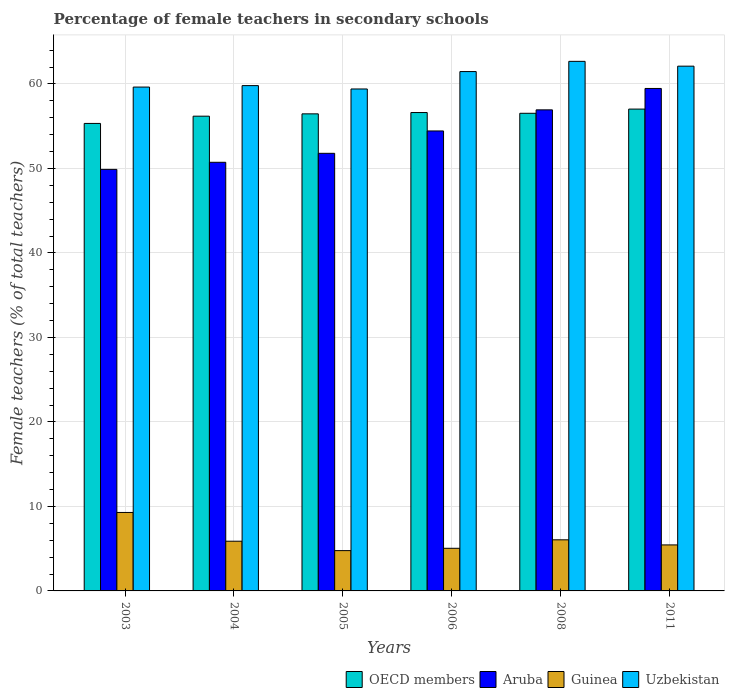Are the number of bars per tick equal to the number of legend labels?
Your response must be concise. Yes. Are the number of bars on each tick of the X-axis equal?
Offer a very short reply. Yes. What is the label of the 4th group of bars from the left?
Keep it short and to the point. 2006. What is the percentage of female teachers in Aruba in 2008?
Your response must be concise. 56.94. Across all years, what is the maximum percentage of female teachers in Aruba?
Offer a terse response. 59.47. Across all years, what is the minimum percentage of female teachers in Aruba?
Provide a succinct answer. 49.89. What is the total percentage of female teachers in Uzbekistan in the graph?
Provide a short and direct response. 365.1. What is the difference between the percentage of female teachers in Guinea in 2005 and that in 2006?
Your answer should be very brief. -0.28. What is the difference between the percentage of female teachers in Uzbekistan in 2011 and the percentage of female teachers in Guinea in 2008?
Make the answer very short. 56.06. What is the average percentage of female teachers in Guinea per year?
Offer a very short reply. 6.08. In the year 2006, what is the difference between the percentage of female teachers in OECD members and percentage of female teachers in Aruba?
Your response must be concise. 2.18. What is the ratio of the percentage of female teachers in Aruba in 2003 to that in 2006?
Provide a succinct answer. 0.92. Is the percentage of female teachers in OECD members in 2003 less than that in 2011?
Your answer should be compact. Yes. Is the difference between the percentage of female teachers in OECD members in 2003 and 2006 greater than the difference between the percentage of female teachers in Aruba in 2003 and 2006?
Make the answer very short. Yes. What is the difference between the highest and the second highest percentage of female teachers in Aruba?
Ensure brevity in your answer.  2.53. What is the difference between the highest and the lowest percentage of female teachers in OECD members?
Keep it short and to the point. 1.7. What does the 3rd bar from the left in 2003 represents?
Offer a terse response. Guinea. What does the 3rd bar from the right in 2003 represents?
Make the answer very short. Aruba. Are all the bars in the graph horizontal?
Your answer should be compact. No. How many years are there in the graph?
Give a very brief answer. 6. What is the difference between two consecutive major ticks on the Y-axis?
Ensure brevity in your answer.  10. Are the values on the major ticks of Y-axis written in scientific E-notation?
Make the answer very short. No. Where does the legend appear in the graph?
Keep it short and to the point. Bottom right. How are the legend labels stacked?
Offer a terse response. Horizontal. What is the title of the graph?
Offer a terse response. Percentage of female teachers in secondary schools. Does "Latin America(developing only)" appear as one of the legend labels in the graph?
Ensure brevity in your answer.  No. What is the label or title of the X-axis?
Your answer should be compact. Years. What is the label or title of the Y-axis?
Your answer should be compact. Female teachers (% of total teachers). What is the Female teachers (% of total teachers) in OECD members in 2003?
Offer a very short reply. 55.33. What is the Female teachers (% of total teachers) of Aruba in 2003?
Your answer should be very brief. 49.89. What is the Female teachers (% of total teachers) in Guinea in 2003?
Ensure brevity in your answer.  9.29. What is the Female teachers (% of total teachers) of Uzbekistan in 2003?
Your answer should be very brief. 59.63. What is the Female teachers (% of total teachers) in OECD members in 2004?
Your answer should be very brief. 56.19. What is the Female teachers (% of total teachers) in Aruba in 2004?
Provide a succinct answer. 50.73. What is the Female teachers (% of total teachers) of Guinea in 2004?
Your answer should be compact. 5.88. What is the Female teachers (% of total teachers) of Uzbekistan in 2004?
Your response must be concise. 59.81. What is the Female teachers (% of total teachers) of OECD members in 2005?
Your answer should be compact. 56.46. What is the Female teachers (% of total teachers) in Aruba in 2005?
Provide a short and direct response. 51.79. What is the Female teachers (% of total teachers) in Guinea in 2005?
Offer a terse response. 4.77. What is the Female teachers (% of total teachers) in Uzbekistan in 2005?
Your answer should be very brief. 59.41. What is the Female teachers (% of total teachers) of OECD members in 2006?
Make the answer very short. 56.62. What is the Female teachers (% of total teachers) of Aruba in 2006?
Ensure brevity in your answer.  54.44. What is the Female teachers (% of total teachers) of Guinea in 2006?
Provide a succinct answer. 5.05. What is the Female teachers (% of total teachers) in Uzbekistan in 2006?
Offer a very short reply. 61.47. What is the Female teachers (% of total teachers) of OECD members in 2008?
Offer a very short reply. 56.53. What is the Female teachers (% of total teachers) of Aruba in 2008?
Your response must be concise. 56.94. What is the Female teachers (% of total teachers) of Guinea in 2008?
Keep it short and to the point. 6.05. What is the Female teachers (% of total teachers) of Uzbekistan in 2008?
Ensure brevity in your answer.  62.68. What is the Female teachers (% of total teachers) in OECD members in 2011?
Your response must be concise. 57.03. What is the Female teachers (% of total teachers) in Aruba in 2011?
Keep it short and to the point. 59.47. What is the Female teachers (% of total teachers) in Guinea in 2011?
Keep it short and to the point. 5.44. What is the Female teachers (% of total teachers) of Uzbekistan in 2011?
Keep it short and to the point. 62.11. Across all years, what is the maximum Female teachers (% of total teachers) of OECD members?
Your answer should be compact. 57.03. Across all years, what is the maximum Female teachers (% of total teachers) of Aruba?
Ensure brevity in your answer.  59.47. Across all years, what is the maximum Female teachers (% of total teachers) of Guinea?
Your response must be concise. 9.29. Across all years, what is the maximum Female teachers (% of total teachers) in Uzbekistan?
Provide a succinct answer. 62.68. Across all years, what is the minimum Female teachers (% of total teachers) of OECD members?
Provide a succinct answer. 55.33. Across all years, what is the minimum Female teachers (% of total teachers) of Aruba?
Your answer should be very brief. 49.89. Across all years, what is the minimum Female teachers (% of total teachers) in Guinea?
Offer a terse response. 4.77. Across all years, what is the minimum Female teachers (% of total teachers) of Uzbekistan?
Your answer should be very brief. 59.41. What is the total Female teachers (% of total teachers) of OECD members in the graph?
Offer a terse response. 338.16. What is the total Female teachers (% of total teachers) in Aruba in the graph?
Make the answer very short. 323.26. What is the total Female teachers (% of total teachers) of Guinea in the graph?
Provide a succinct answer. 36.48. What is the total Female teachers (% of total teachers) of Uzbekistan in the graph?
Keep it short and to the point. 365.1. What is the difference between the Female teachers (% of total teachers) in OECD members in 2003 and that in 2004?
Provide a short and direct response. -0.86. What is the difference between the Female teachers (% of total teachers) of Aruba in 2003 and that in 2004?
Make the answer very short. -0.84. What is the difference between the Female teachers (% of total teachers) of Guinea in 2003 and that in 2004?
Provide a succinct answer. 3.4. What is the difference between the Female teachers (% of total teachers) of Uzbekistan in 2003 and that in 2004?
Make the answer very short. -0.17. What is the difference between the Female teachers (% of total teachers) in OECD members in 2003 and that in 2005?
Your answer should be very brief. -1.13. What is the difference between the Female teachers (% of total teachers) in Aruba in 2003 and that in 2005?
Keep it short and to the point. -1.9. What is the difference between the Female teachers (% of total teachers) of Guinea in 2003 and that in 2005?
Offer a terse response. 4.52. What is the difference between the Female teachers (% of total teachers) in Uzbekistan in 2003 and that in 2005?
Offer a very short reply. 0.22. What is the difference between the Female teachers (% of total teachers) of OECD members in 2003 and that in 2006?
Your answer should be very brief. -1.29. What is the difference between the Female teachers (% of total teachers) of Aruba in 2003 and that in 2006?
Provide a short and direct response. -4.55. What is the difference between the Female teachers (% of total teachers) in Guinea in 2003 and that in 2006?
Provide a short and direct response. 4.24. What is the difference between the Female teachers (% of total teachers) in Uzbekistan in 2003 and that in 2006?
Your answer should be compact. -1.84. What is the difference between the Female teachers (% of total teachers) of OECD members in 2003 and that in 2008?
Your answer should be very brief. -1.2. What is the difference between the Female teachers (% of total teachers) in Aruba in 2003 and that in 2008?
Provide a succinct answer. -7.05. What is the difference between the Female teachers (% of total teachers) in Guinea in 2003 and that in 2008?
Keep it short and to the point. 3.24. What is the difference between the Female teachers (% of total teachers) in Uzbekistan in 2003 and that in 2008?
Your response must be concise. -3.04. What is the difference between the Female teachers (% of total teachers) of OECD members in 2003 and that in 2011?
Give a very brief answer. -1.7. What is the difference between the Female teachers (% of total teachers) in Aruba in 2003 and that in 2011?
Ensure brevity in your answer.  -9.58. What is the difference between the Female teachers (% of total teachers) of Guinea in 2003 and that in 2011?
Your response must be concise. 3.84. What is the difference between the Female teachers (% of total teachers) in Uzbekistan in 2003 and that in 2011?
Offer a terse response. -2.47. What is the difference between the Female teachers (% of total teachers) of OECD members in 2004 and that in 2005?
Offer a terse response. -0.28. What is the difference between the Female teachers (% of total teachers) of Aruba in 2004 and that in 2005?
Offer a terse response. -1.06. What is the difference between the Female teachers (% of total teachers) in Guinea in 2004 and that in 2005?
Provide a short and direct response. 1.11. What is the difference between the Female teachers (% of total teachers) of Uzbekistan in 2004 and that in 2005?
Your answer should be compact. 0.4. What is the difference between the Female teachers (% of total teachers) of OECD members in 2004 and that in 2006?
Offer a very short reply. -0.43. What is the difference between the Female teachers (% of total teachers) of Aruba in 2004 and that in 2006?
Provide a succinct answer. -3.71. What is the difference between the Female teachers (% of total teachers) of Guinea in 2004 and that in 2006?
Ensure brevity in your answer.  0.84. What is the difference between the Female teachers (% of total teachers) of Uzbekistan in 2004 and that in 2006?
Give a very brief answer. -1.66. What is the difference between the Female teachers (% of total teachers) in OECD members in 2004 and that in 2008?
Keep it short and to the point. -0.34. What is the difference between the Female teachers (% of total teachers) in Aruba in 2004 and that in 2008?
Your answer should be very brief. -6.21. What is the difference between the Female teachers (% of total teachers) in Guinea in 2004 and that in 2008?
Make the answer very short. -0.16. What is the difference between the Female teachers (% of total teachers) of Uzbekistan in 2004 and that in 2008?
Provide a succinct answer. -2.87. What is the difference between the Female teachers (% of total teachers) of OECD members in 2004 and that in 2011?
Keep it short and to the point. -0.84. What is the difference between the Female teachers (% of total teachers) of Aruba in 2004 and that in 2011?
Make the answer very short. -8.74. What is the difference between the Female teachers (% of total teachers) of Guinea in 2004 and that in 2011?
Your answer should be compact. 0.44. What is the difference between the Female teachers (% of total teachers) of Uzbekistan in 2004 and that in 2011?
Offer a terse response. -2.3. What is the difference between the Female teachers (% of total teachers) in OECD members in 2005 and that in 2006?
Offer a very short reply. -0.16. What is the difference between the Female teachers (% of total teachers) of Aruba in 2005 and that in 2006?
Give a very brief answer. -2.65. What is the difference between the Female teachers (% of total teachers) of Guinea in 2005 and that in 2006?
Offer a terse response. -0.28. What is the difference between the Female teachers (% of total teachers) of Uzbekistan in 2005 and that in 2006?
Your response must be concise. -2.06. What is the difference between the Female teachers (% of total teachers) of OECD members in 2005 and that in 2008?
Keep it short and to the point. -0.07. What is the difference between the Female teachers (% of total teachers) in Aruba in 2005 and that in 2008?
Your response must be concise. -5.14. What is the difference between the Female teachers (% of total teachers) in Guinea in 2005 and that in 2008?
Make the answer very short. -1.28. What is the difference between the Female teachers (% of total teachers) in Uzbekistan in 2005 and that in 2008?
Your answer should be very brief. -3.27. What is the difference between the Female teachers (% of total teachers) in OECD members in 2005 and that in 2011?
Your answer should be compact. -0.56. What is the difference between the Female teachers (% of total teachers) of Aruba in 2005 and that in 2011?
Ensure brevity in your answer.  -7.68. What is the difference between the Female teachers (% of total teachers) in Guinea in 2005 and that in 2011?
Ensure brevity in your answer.  -0.67. What is the difference between the Female teachers (% of total teachers) of Uzbekistan in 2005 and that in 2011?
Keep it short and to the point. -2.7. What is the difference between the Female teachers (% of total teachers) of OECD members in 2006 and that in 2008?
Ensure brevity in your answer.  0.09. What is the difference between the Female teachers (% of total teachers) of Aruba in 2006 and that in 2008?
Your response must be concise. -2.5. What is the difference between the Female teachers (% of total teachers) in Guinea in 2006 and that in 2008?
Your answer should be very brief. -1. What is the difference between the Female teachers (% of total teachers) in Uzbekistan in 2006 and that in 2008?
Make the answer very short. -1.21. What is the difference between the Female teachers (% of total teachers) in OECD members in 2006 and that in 2011?
Your answer should be compact. -0.41. What is the difference between the Female teachers (% of total teachers) in Aruba in 2006 and that in 2011?
Keep it short and to the point. -5.03. What is the difference between the Female teachers (% of total teachers) of Guinea in 2006 and that in 2011?
Provide a short and direct response. -0.4. What is the difference between the Female teachers (% of total teachers) in Uzbekistan in 2006 and that in 2011?
Keep it short and to the point. -0.64. What is the difference between the Female teachers (% of total teachers) of OECD members in 2008 and that in 2011?
Provide a succinct answer. -0.5. What is the difference between the Female teachers (% of total teachers) in Aruba in 2008 and that in 2011?
Offer a terse response. -2.53. What is the difference between the Female teachers (% of total teachers) of Guinea in 2008 and that in 2011?
Your answer should be compact. 0.6. What is the difference between the Female teachers (% of total teachers) of Uzbekistan in 2008 and that in 2011?
Provide a succinct answer. 0.57. What is the difference between the Female teachers (% of total teachers) of OECD members in 2003 and the Female teachers (% of total teachers) of Aruba in 2004?
Offer a terse response. 4.6. What is the difference between the Female teachers (% of total teachers) in OECD members in 2003 and the Female teachers (% of total teachers) in Guinea in 2004?
Offer a very short reply. 49.45. What is the difference between the Female teachers (% of total teachers) in OECD members in 2003 and the Female teachers (% of total teachers) in Uzbekistan in 2004?
Give a very brief answer. -4.48. What is the difference between the Female teachers (% of total teachers) in Aruba in 2003 and the Female teachers (% of total teachers) in Guinea in 2004?
Make the answer very short. 44.01. What is the difference between the Female teachers (% of total teachers) of Aruba in 2003 and the Female teachers (% of total teachers) of Uzbekistan in 2004?
Your response must be concise. -9.91. What is the difference between the Female teachers (% of total teachers) of Guinea in 2003 and the Female teachers (% of total teachers) of Uzbekistan in 2004?
Provide a short and direct response. -50.52. What is the difference between the Female teachers (% of total teachers) of OECD members in 2003 and the Female teachers (% of total teachers) of Aruba in 2005?
Ensure brevity in your answer.  3.54. What is the difference between the Female teachers (% of total teachers) in OECD members in 2003 and the Female teachers (% of total teachers) in Guinea in 2005?
Give a very brief answer. 50.56. What is the difference between the Female teachers (% of total teachers) in OECD members in 2003 and the Female teachers (% of total teachers) in Uzbekistan in 2005?
Your answer should be very brief. -4.08. What is the difference between the Female teachers (% of total teachers) in Aruba in 2003 and the Female teachers (% of total teachers) in Guinea in 2005?
Make the answer very short. 45.12. What is the difference between the Female teachers (% of total teachers) in Aruba in 2003 and the Female teachers (% of total teachers) in Uzbekistan in 2005?
Offer a very short reply. -9.52. What is the difference between the Female teachers (% of total teachers) in Guinea in 2003 and the Female teachers (% of total teachers) in Uzbekistan in 2005?
Make the answer very short. -50.12. What is the difference between the Female teachers (% of total teachers) of OECD members in 2003 and the Female teachers (% of total teachers) of Aruba in 2006?
Provide a short and direct response. 0.89. What is the difference between the Female teachers (% of total teachers) of OECD members in 2003 and the Female teachers (% of total teachers) of Guinea in 2006?
Keep it short and to the point. 50.28. What is the difference between the Female teachers (% of total teachers) of OECD members in 2003 and the Female teachers (% of total teachers) of Uzbekistan in 2006?
Offer a very short reply. -6.14. What is the difference between the Female teachers (% of total teachers) in Aruba in 2003 and the Female teachers (% of total teachers) in Guinea in 2006?
Give a very brief answer. 44.85. What is the difference between the Female teachers (% of total teachers) of Aruba in 2003 and the Female teachers (% of total teachers) of Uzbekistan in 2006?
Your response must be concise. -11.58. What is the difference between the Female teachers (% of total teachers) of Guinea in 2003 and the Female teachers (% of total teachers) of Uzbekistan in 2006?
Ensure brevity in your answer.  -52.18. What is the difference between the Female teachers (% of total teachers) in OECD members in 2003 and the Female teachers (% of total teachers) in Aruba in 2008?
Provide a short and direct response. -1.61. What is the difference between the Female teachers (% of total teachers) of OECD members in 2003 and the Female teachers (% of total teachers) of Guinea in 2008?
Provide a short and direct response. 49.28. What is the difference between the Female teachers (% of total teachers) of OECD members in 2003 and the Female teachers (% of total teachers) of Uzbekistan in 2008?
Offer a terse response. -7.35. What is the difference between the Female teachers (% of total teachers) of Aruba in 2003 and the Female teachers (% of total teachers) of Guinea in 2008?
Offer a very short reply. 43.84. What is the difference between the Female teachers (% of total teachers) in Aruba in 2003 and the Female teachers (% of total teachers) in Uzbekistan in 2008?
Ensure brevity in your answer.  -12.79. What is the difference between the Female teachers (% of total teachers) in Guinea in 2003 and the Female teachers (% of total teachers) in Uzbekistan in 2008?
Make the answer very short. -53.39. What is the difference between the Female teachers (% of total teachers) in OECD members in 2003 and the Female teachers (% of total teachers) in Aruba in 2011?
Ensure brevity in your answer.  -4.14. What is the difference between the Female teachers (% of total teachers) in OECD members in 2003 and the Female teachers (% of total teachers) in Guinea in 2011?
Ensure brevity in your answer.  49.89. What is the difference between the Female teachers (% of total teachers) in OECD members in 2003 and the Female teachers (% of total teachers) in Uzbekistan in 2011?
Give a very brief answer. -6.78. What is the difference between the Female teachers (% of total teachers) of Aruba in 2003 and the Female teachers (% of total teachers) of Guinea in 2011?
Your answer should be compact. 44.45. What is the difference between the Female teachers (% of total teachers) in Aruba in 2003 and the Female teachers (% of total teachers) in Uzbekistan in 2011?
Give a very brief answer. -12.22. What is the difference between the Female teachers (% of total teachers) in Guinea in 2003 and the Female teachers (% of total teachers) in Uzbekistan in 2011?
Offer a very short reply. -52.82. What is the difference between the Female teachers (% of total teachers) in OECD members in 2004 and the Female teachers (% of total teachers) in Aruba in 2005?
Your response must be concise. 4.4. What is the difference between the Female teachers (% of total teachers) of OECD members in 2004 and the Female teachers (% of total teachers) of Guinea in 2005?
Ensure brevity in your answer.  51.42. What is the difference between the Female teachers (% of total teachers) in OECD members in 2004 and the Female teachers (% of total teachers) in Uzbekistan in 2005?
Provide a short and direct response. -3.22. What is the difference between the Female teachers (% of total teachers) in Aruba in 2004 and the Female teachers (% of total teachers) in Guinea in 2005?
Offer a terse response. 45.96. What is the difference between the Female teachers (% of total teachers) in Aruba in 2004 and the Female teachers (% of total teachers) in Uzbekistan in 2005?
Offer a terse response. -8.68. What is the difference between the Female teachers (% of total teachers) in Guinea in 2004 and the Female teachers (% of total teachers) in Uzbekistan in 2005?
Offer a terse response. -53.53. What is the difference between the Female teachers (% of total teachers) of OECD members in 2004 and the Female teachers (% of total teachers) of Aruba in 2006?
Your answer should be very brief. 1.75. What is the difference between the Female teachers (% of total teachers) of OECD members in 2004 and the Female teachers (% of total teachers) of Guinea in 2006?
Provide a succinct answer. 51.14. What is the difference between the Female teachers (% of total teachers) in OECD members in 2004 and the Female teachers (% of total teachers) in Uzbekistan in 2006?
Provide a short and direct response. -5.28. What is the difference between the Female teachers (% of total teachers) of Aruba in 2004 and the Female teachers (% of total teachers) of Guinea in 2006?
Your answer should be very brief. 45.69. What is the difference between the Female teachers (% of total teachers) in Aruba in 2004 and the Female teachers (% of total teachers) in Uzbekistan in 2006?
Provide a short and direct response. -10.74. What is the difference between the Female teachers (% of total teachers) of Guinea in 2004 and the Female teachers (% of total teachers) of Uzbekistan in 2006?
Make the answer very short. -55.59. What is the difference between the Female teachers (% of total teachers) of OECD members in 2004 and the Female teachers (% of total teachers) of Aruba in 2008?
Provide a succinct answer. -0.75. What is the difference between the Female teachers (% of total teachers) of OECD members in 2004 and the Female teachers (% of total teachers) of Guinea in 2008?
Your answer should be compact. 50.14. What is the difference between the Female teachers (% of total teachers) in OECD members in 2004 and the Female teachers (% of total teachers) in Uzbekistan in 2008?
Your answer should be very brief. -6.49. What is the difference between the Female teachers (% of total teachers) of Aruba in 2004 and the Female teachers (% of total teachers) of Guinea in 2008?
Your response must be concise. 44.68. What is the difference between the Female teachers (% of total teachers) in Aruba in 2004 and the Female teachers (% of total teachers) in Uzbekistan in 2008?
Ensure brevity in your answer.  -11.95. What is the difference between the Female teachers (% of total teachers) of Guinea in 2004 and the Female teachers (% of total teachers) of Uzbekistan in 2008?
Provide a short and direct response. -56.79. What is the difference between the Female teachers (% of total teachers) of OECD members in 2004 and the Female teachers (% of total teachers) of Aruba in 2011?
Your answer should be very brief. -3.28. What is the difference between the Female teachers (% of total teachers) in OECD members in 2004 and the Female teachers (% of total teachers) in Guinea in 2011?
Offer a terse response. 50.74. What is the difference between the Female teachers (% of total teachers) of OECD members in 2004 and the Female teachers (% of total teachers) of Uzbekistan in 2011?
Your answer should be compact. -5.92. What is the difference between the Female teachers (% of total teachers) in Aruba in 2004 and the Female teachers (% of total teachers) in Guinea in 2011?
Give a very brief answer. 45.29. What is the difference between the Female teachers (% of total teachers) in Aruba in 2004 and the Female teachers (% of total teachers) in Uzbekistan in 2011?
Your answer should be compact. -11.38. What is the difference between the Female teachers (% of total teachers) in Guinea in 2004 and the Female teachers (% of total teachers) in Uzbekistan in 2011?
Offer a very short reply. -56.22. What is the difference between the Female teachers (% of total teachers) of OECD members in 2005 and the Female teachers (% of total teachers) of Aruba in 2006?
Your answer should be compact. 2.02. What is the difference between the Female teachers (% of total teachers) in OECD members in 2005 and the Female teachers (% of total teachers) in Guinea in 2006?
Provide a succinct answer. 51.42. What is the difference between the Female teachers (% of total teachers) in OECD members in 2005 and the Female teachers (% of total teachers) in Uzbekistan in 2006?
Keep it short and to the point. -5. What is the difference between the Female teachers (% of total teachers) of Aruba in 2005 and the Female teachers (% of total teachers) of Guinea in 2006?
Provide a short and direct response. 46.75. What is the difference between the Female teachers (% of total teachers) in Aruba in 2005 and the Female teachers (% of total teachers) in Uzbekistan in 2006?
Ensure brevity in your answer.  -9.68. What is the difference between the Female teachers (% of total teachers) in Guinea in 2005 and the Female teachers (% of total teachers) in Uzbekistan in 2006?
Your answer should be compact. -56.7. What is the difference between the Female teachers (% of total teachers) of OECD members in 2005 and the Female teachers (% of total teachers) of Aruba in 2008?
Offer a terse response. -0.47. What is the difference between the Female teachers (% of total teachers) in OECD members in 2005 and the Female teachers (% of total teachers) in Guinea in 2008?
Give a very brief answer. 50.42. What is the difference between the Female teachers (% of total teachers) in OECD members in 2005 and the Female teachers (% of total teachers) in Uzbekistan in 2008?
Provide a succinct answer. -6.21. What is the difference between the Female teachers (% of total teachers) of Aruba in 2005 and the Female teachers (% of total teachers) of Guinea in 2008?
Offer a terse response. 45.75. What is the difference between the Female teachers (% of total teachers) of Aruba in 2005 and the Female teachers (% of total teachers) of Uzbekistan in 2008?
Your answer should be very brief. -10.88. What is the difference between the Female teachers (% of total teachers) of Guinea in 2005 and the Female teachers (% of total teachers) of Uzbekistan in 2008?
Your response must be concise. -57.91. What is the difference between the Female teachers (% of total teachers) in OECD members in 2005 and the Female teachers (% of total teachers) in Aruba in 2011?
Your answer should be very brief. -3.01. What is the difference between the Female teachers (% of total teachers) in OECD members in 2005 and the Female teachers (% of total teachers) in Guinea in 2011?
Your answer should be compact. 51.02. What is the difference between the Female teachers (% of total teachers) in OECD members in 2005 and the Female teachers (% of total teachers) in Uzbekistan in 2011?
Provide a short and direct response. -5.64. What is the difference between the Female teachers (% of total teachers) in Aruba in 2005 and the Female teachers (% of total teachers) in Guinea in 2011?
Provide a succinct answer. 46.35. What is the difference between the Female teachers (% of total teachers) of Aruba in 2005 and the Female teachers (% of total teachers) of Uzbekistan in 2011?
Your answer should be very brief. -10.31. What is the difference between the Female teachers (% of total teachers) in Guinea in 2005 and the Female teachers (% of total teachers) in Uzbekistan in 2011?
Give a very brief answer. -57.34. What is the difference between the Female teachers (% of total teachers) in OECD members in 2006 and the Female teachers (% of total teachers) in Aruba in 2008?
Make the answer very short. -0.32. What is the difference between the Female teachers (% of total teachers) of OECD members in 2006 and the Female teachers (% of total teachers) of Guinea in 2008?
Provide a short and direct response. 50.57. What is the difference between the Female teachers (% of total teachers) in OECD members in 2006 and the Female teachers (% of total teachers) in Uzbekistan in 2008?
Make the answer very short. -6.06. What is the difference between the Female teachers (% of total teachers) of Aruba in 2006 and the Female teachers (% of total teachers) of Guinea in 2008?
Ensure brevity in your answer.  48.39. What is the difference between the Female teachers (% of total teachers) in Aruba in 2006 and the Female teachers (% of total teachers) in Uzbekistan in 2008?
Offer a terse response. -8.24. What is the difference between the Female teachers (% of total teachers) in Guinea in 2006 and the Female teachers (% of total teachers) in Uzbekistan in 2008?
Your answer should be compact. -57.63. What is the difference between the Female teachers (% of total teachers) of OECD members in 2006 and the Female teachers (% of total teachers) of Aruba in 2011?
Ensure brevity in your answer.  -2.85. What is the difference between the Female teachers (% of total teachers) in OECD members in 2006 and the Female teachers (% of total teachers) in Guinea in 2011?
Your answer should be very brief. 51.18. What is the difference between the Female teachers (% of total teachers) of OECD members in 2006 and the Female teachers (% of total teachers) of Uzbekistan in 2011?
Your answer should be compact. -5.49. What is the difference between the Female teachers (% of total teachers) of Aruba in 2006 and the Female teachers (% of total teachers) of Guinea in 2011?
Ensure brevity in your answer.  49. What is the difference between the Female teachers (% of total teachers) of Aruba in 2006 and the Female teachers (% of total teachers) of Uzbekistan in 2011?
Provide a succinct answer. -7.67. What is the difference between the Female teachers (% of total teachers) of Guinea in 2006 and the Female teachers (% of total teachers) of Uzbekistan in 2011?
Make the answer very short. -57.06. What is the difference between the Female teachers (% of total teachers) of OECD members in 2008 and the Female teachers (% of total teachers) of Aruba in 2011?
Your answer should be compact. -2.94. What is the difference between the Female teachers (% of total teachers) in OECD members in 2008 and the Female teachers (% of total teachers) in Guinea in 2011?
Your answer should be very brief. 51.09. What is the difference between the Female teachers (% of total teachers) in OECD members in 2008 and the Female teachers (% of total teachers) in Uzbekistan in 2011?
Your response must be concise. -5.58. What is the difference between the Female teachers (% of total teachers) of Aruba in 2008 and the Female teachers (% of total teachers) of Guinea in 2011?
Make the answer very short. 51.49. What is the difference between the Female teachers (% of total teachers) of Aruba in 2008 and the Female teachers (% of total teachers) of Uzbekistan in 2011?
Ensure brevity in your answer.  -5.17. What is the difference between the Female teachers (% of total teachers) of Guinea in 2008 and the Female teachers (% of total teachers) of Uzbekistan in 2011?
Your response must be concise. -56.06. What is the average Female teachers (% of total teachers) of OECD members per year?
Provide a short and direct response. 56.36. What is the average Female teachers (% of total teachers) of Aruba per year?
Your answer should be compact. 53.88. What is the average Female teachers (% of total teachers) in Guinea per year?
Provide a short and direct response. 6.08. What is the average Female teachers (% of total teachers) in Uzbekistan per year?
Your answer should be compact. 60.85. In the year 2003, what is the difference between the Female teachers (% of total teachers) in OECD members and Female teachers (% of total teachers) in Aruba?
Your response must be concise. 5.44. In the year 2003, what is the difference between the Female teachers (% of total teachers) of OECD members and Female teachers (% of total teachers) of Guinea?
Provide a succinct answer. 46.04. In the year 2003, what is the difference between the Female teachers (% of total teachers) in OECD members and Female teachers (% of total teachers) in Uzbekistan?
Provide a short and direct response. -4.3. In the year 2003, what is the difference between the Female teachers (% of total teachers) in Aruba and Female teachers (% of total teachers) in Guinea?
Ensure brevity in your answer.  40.61. In the year 2003, what is the difference between the Female teachers (% of total teachers) of Aruba and Female teachers (% of total teachers) of Uzbekistan?
Your answer should be compact. -9.74. In the year 2003, what is the difference between the Female teachers (% of total teachers) of Guinea and Female teachers (% of total teachers) of Uzbekistan?
Offer a very short reply. -50.35. In the year 2004, what is the difference between the Female teachers (% of total teachers) of OECD members and Female teachers (% of total teachers) of Aruba?
Make the answer very short. 5.46. In the year 2004, what is the difference between the Female teachers (% of total teachers) in OECD members and Female teachers (% of total teachers) in Guinea?
Keep it short and to the point. 50.31. In the year 2004, what is the difference between the Female teachers (% of total teachers) of OECD members and Female teachers (% of total teachers) of Uzbekistan?
Provide a succinct answer. -3.62. In the year 2004, what is the difference between the Female teachers (% of total teachers) in Aruba and Female teachers (% of total teachers) in Guinea?
Offer a very short reply. 44.85. In the year 2004, what is the difference between the Female teachers (% of total teachers) in Aruba and Female teachers (% of total teachers) in Uzbekistan?
Make the answer very short. -9.08. In the year 2004, what is the difference between the Female teachers (% of total teachers) of Guinea and Female teachers (% of total teachers) of Uzbekistan?
Provide a succinct answer. -53.92. In the year 2005, what is the difference between the Female teachers (% of total teachers) of OECD members and Female teachers (% of total teachers) of Aruba?
Offer a very short reply. 4.67. In the year 2005, what is the difference between the Female teachers (% of total teachers) in OECD members and Female teachers (% of total teachers) in Guinea?
Ensure brevity in your answer.  51.69. In the year 2005, what is the difference between the Female teachers (% of total teachers) in OECD members and Female teachers (% of total teachers) in Uzbekistan?
Provide a short and direct response. -2.94. In the year 2005, what is the difference between the Female teachers (% of total teachers) in Aruba and Female teachers (% of total teachers) in Guinea?
Offer a very short reply. 47.02. In the year 2005, what is the difference between the Female teachers (% of total teachers) of Aruba and Female teachers (% of total teachers) of Uzbekistan?
Make the answer very short. -7.62. In the year 2005, what is the difference between the Female teachers (% of total teachers) in Guinea and Female teachers (% of total teachers) in Uzbekistan?
Keep it short and to the point. -54.64. In the year 2006, what is the difference between the Female teachers (% of total teachers) of OECD members and Female teachers (% of total teachers) of Aruba?
Provide a short and direct response. 2.18. In the year 2006, what is the difference between the Female teachers (% of total teachers) in OECD members and Female teachers (% of total teachers) in Guinea?
Make the answer very short. 51.57. In the year 2006, what is the difference between the Female teachers (% of total teachers) in OECD members and Female teachers (% of total teachers) in Uzbekistan?
Your answer should be very brief. -4.85. In the year 2006, what is the difference between the Female teachers (% of total teachers) of Aruba and Female teachers (% of total teachers) of Guinea?
Ensure brevity in your answer.  49.39. In the year 2006, what is the difference between the Female teachers (% of total teachers) in Aruba and Female teachers (% of total teachers) in Uzbekistan?
Ensure brevity in your answer.  -7.03. In the year 2006, what is the difference between the Female teachers (% of total teachers) of Guinea and Female teachers (% of total teachers) of Uzbekistan?
Keep it short and to the point. -56.42. In the year 2008, what is the difference between the Female teachers (% of total teachers) in OECD members and Female teachers (% of total teachers) in Aruba?
Your answer should be compact. -0.41. In the year 2008, what is the difference between the Female teachers (% of total teachers) of OECD members and Female teachers (% of total teachers) of Guinea?
Your answer should be very brief. 50.48. In the year 2008, what is the difference between the Female teachers (% of total teachers) of OECD members and Female teachers (% of total teachers) of Uzbekistan?
Make the answer very short. -6.15. In the year 2008, what is the difference between the Female teachers (% of total teachers) of Aruba and Female teachers (% of total teachers) of Guinea?
Ensure brevity in your answer.  50.89. In the year 2008, what is the difference between the Female teachers (% of total teachers) of Aruba and Female teachers (% of total teachers) of Uzbekistan?
Offer a terse response. -5.74. In the year 2008, what is the difference between the Female teachers (% of total teachers) in Guinea and Female teachers (% of total teachers) in Uzbekistan?
Offer a terse response. -56.63. In the year 2011, what is the difference between the Female teachers (% of total teachers) of OECD members and Female teachers (% of total teachers) of Aruba?
Offer a terse response. -2.44. In the year 2011, what is the difference between the Female teachers (% of total teachers) of OECD members and Female teachers (% of total teachers) of Guinea?
Provide a succinct answer. 51.58. In the year 2011, what is the difference between the Female teachers (% of total teachers) in OECD members and Female teachers (% of total teachers) in Uzbekistan?
Offer a terse response. -5.08. In the year 2011, what is the difference between the Female teachers (% of total teachers) of Aruba and Female teachers (% of total teachers) of Guinea?
Offer a terse response. 54.03. In the year 2011, what is the difference between the Female teachers (% of total teachers) in Aruba and Female teachers (% of total teachers) in Uzbekistan?
Provide a succinct answer. -2.64. In the year 2011, what is the difference between the Female teachers (% of total teachers) of Guinea and Female teachers (% of total teachers) of Uzbekistan?
Provide a short and direct response. -56.66. What is the ratio of the Female teachers (% of total teachers) of OECD members in 2003 to that in 2004?
Your answer should be compact. 0.98. What is the ratio of the Female teachers (% of total teachers) in Aruba in 2003 to that in 2004?
Your answer should be compact. 0.98. What is the ratio of the Female teachers (% of total teachers) of Guinea in 2003 to that in 2004?
Give a very brief answer. 1.58. What is the ratio of the Female teachers (% of total teachers) of OECD members in 2003 to that in 2005?
Provide a short and direct response. 0.98. What is the ratio of the Female teachers (% of total teachers) in Aruba in 2003 to that in 2005?
Provide a short and direct response. 0.96. What is the ratio of the Female teachers (% of total teachers) of Guinea in 2003 to that in 2005?
Keep it short and to the point. 1.95. What is the ratio of the Female teachers (% of total teachers) of OECD members in 2003 to that in 2006?
Offer a terse response. 0.98. What is the ratio of the Female teachers (% of total teachers) of Aruba in 2003 to that in 2006?
Offer a very short reply. 0.92. What is the ratio of the Female teachers (% of total teachers) of Guinea in 2003 to that in 2006?
Your response must be concise. 1.84. What is the ratio of the Female teachers (% of total teachers) of Uzbekistan in 2003 to that in 2006?
Offer a terse response. 0.97. What is the ratio of the Female teachers (% of total teachers) in OECD members in 2003 to that in 2008?
Make the answer very short. 0.98. What is the ratio of the Female teachers (% of total teachers) in Aruba in 2003 to that in 2008?
Your answer should be very brief. 0.88. What is the ratio of the Female teachers (% of total teachers) in Guinea in 2003 to that in 2008?
Your answer should be compact. 1.54. What is the ratio of the Female teachers (% of total teachers) of Uzbekistan in 2003 to that in 2008?
Give a very brief answer. 0.95. What is the ratio of the Female teachers (% of total teachers) of OECD members in 2003 to that in 2011?
Provide a succinct answer. 0.97. What is the ratio of the Female teachers (% of total teachers) in Aruba in 2003 to that in 2011?
Ensure brevity in your answer.  0.84. What is the ratio of the Female teachers (% of total teachers) of Guinea in 2003 to that in 2011?
Ensure brevity in your answer.  1.71. What is the ratio of the Female teachers (% of total teachers) in Uzbekistan in 2003 to that in 2011?
Make the answer very short. 0.96. What is the ratio of the Female teachers (% of total teachers) of Aruba in 2004 to that in 2005?
Offer a terse response. 0.98. What is the ratio of the Female teachers (% of total teachers) of Guinea in 2004 to that in 2005?
Make the answer very short. 1.23. What is the ratio of the Female teachers (% of total teachers) of OECD members in 2004 to that in 2006?
Offer a terse response. 0.99. What is the ratio of the Female teachers (% of total teachers) in Aruba in 2004 to that in 2006?
Keep it short and to the point. 0.93. What is the ratio of the Female teachers (% of total teachers) in Guinea in 2004 to that in 2006?
Keep it short and to the point. 1.17. What is the ratio of the Female teachers (% of total teachers) in Aruba in 2004 to that in 2008?
Keep it short and to the point. 0.89. What is the ratio of the Female teachers (% of total teachers) in Guinea in 2004 to that in 2008?
Provide a short and direct response. 0.97. What is the ratio of the Female teachers (% of total teachers) in Uzbekistan in 2004 to that in 2008?
Offer a very short reply. 0.95. What is the ratio of the Female teachers (% of total teachers) of OECD members in 2004 to that in 2011?
Offer a very short reply. 0.99. What is the ratio of the Female teachers (% of total teachers) of Aruba in 2004 to that in 2011?
Keep it short and to the point. 0.85. What is the ratio of the Female teachers (% of total teachers) of Guinea in 2004 to that in 2011?
Your response must be concise. 1.08. What is the ratio of the Female teachers (% of total teachers) of Uzbekistan in 2004 to that in 2011?
Give a very brief answer. 0.96. What is the ratio of the Female teachers (% of total teachers) in OECD members in 2005 to that in 2006?
Give a very brief answer. 1. What is the ratio of the Female teachers (% of total teachers) of Aruba in 2005 to that in 2006?
Your answer should be compact. 0.95. What is the ratio of the Female teachers (% of total teachers) of Guinea in 2005 to that in 2006?
Provide a succinct answer. 0.95. What is the ratio of the Female teachers (% of total teachers) in Uzbekistan in 2005 to that in 2006?
Keep it short and to the point. 0.97. What is the ratio of the Female teachers (% of total teachers) in OECD members in 2005 to that in 2008?
Your answer should be very brief. 1. What is the ratio of the Female teachers (% of total teachers) in Aruba in 2005 to that in 2008?
Offer a very short reply. 0.91. What is the ratio of the Female teachers (% of total teachers) of Guinea in 2005 to that in 2008?
Make the answer very short. 0.79. What is the ratio of the Female teachers (% of total teachers) in Uzbekistan in 2005 to that in 2008?
Your answer should be very brief. 0.95. What is the ratio of the Female teachers (% of total teachers) in OECD members in 2005 to that in 2011?
Ensure brevity in your answer.  0.99. What is the ratio of the Female teachers (% of total teachers) in Aruba in 2005 to that in 2011?
Offer a terse response. 0.87. What is the ratio of the Female teachers (% of total teachers) of Guinea in 2005 to that in 2011?
Your answer should be very brief. 0.88. What is the ratio of the Female teachers (% of total teachers) of Uzbekistan in 2005 to that in 2011?
Keep it short and to the point. 0.96. What is the ratio of the Female teachers (% of total teachers) of Aruba in 2006 to that in 2008?
Your answer should be compact. 0.96. What is the ratio of the Female teachers (% of total teachers) of Guinea in 2006 to that in 2008?
Offer a terse response. 0.83. What is the ratio of the Female teachers (% of total teachers) of Uzbekistan in 2006 to that in 2008?
Ensure brevity in your answer.  0.98. What is the ratio of the Female teachers (% of total teachers) of Aruba in 2006 to that in 2011?
Provide a succinct answer. 0.92. What is the ratio of the Female teachers (% of total teachers) of Guinea in 2006 to that in 2011?
Your answer should be very brief. 0.93. What is the ratio of the Female teachers (% of total teachers) of Uzbekistan in 2006 to that in 2011?
Provide a succinct answer. 0.99. What is the ratio of the Female teachers (% of total teachers) of OECD members in 2008 to that in 2011?
Offer a very short reply. 0.99. What is the ratio of the Female teachers (% of total teachers) of Aruba in 2008 to that in 2011?
Your response must be concise. 0.96. What is the ratio of the Female teachers (% of total teachers) of Guinea in 2008 to that in 2011?
Keep it short and to the point. 1.11. What is the ratio of the Female teachers (% of total teachers) of Uzbekistan in 2008 to that in 2011?
Your response must be concise. 1.01. What is the difference between the highest and the second highest Female teachers (% of total teachers) in OECD members?
Give a very brief answer. 0.41. What is the difference between the highest and the second highest Female teachers (% of total teachers) of Aruba?
Offer a very short reply. 2.53. What is the difference between the highest and the second highest Female teachers (% of total teachers) in Guinea?
Ensure brevity in your answer.  3.24. What is the difference between the highest and the second highest Female teachers (% of total teachers) in Uzbekistan?
Ensure brevity in your answer.  0.57. What is the difference between the highest and the lowest Female teachers (% of total teachers) of OECD members?
Make the answer very short. 1.7. What is the difference between the highest and the lowest Female teachers (% of total teachers) in Aruba?
Offer a very short reply. 9.58. What is the difference between the highest and the lowest Female teachers (% of total teachers) in Guinea?
Your answer should be very brief. 4.52. What is the difference between the highest and the lowest Female teachers (% of total teachers) in Uzbekistan?
Your answer should be compact. 3.27. 